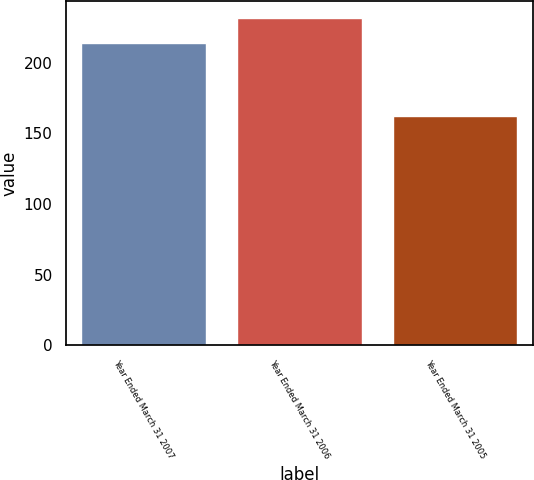Convert chart to OTSL. <chart><loc_0><loc_0><loc_500><loc_500><bar_chart><fcel>Year Ended March 31 2007<fcel>Year Ended March 31 2006<fcel>Year Ended March 31 2005<nl><fcel>214<fcel>232<fcel>162<nl></chart> 